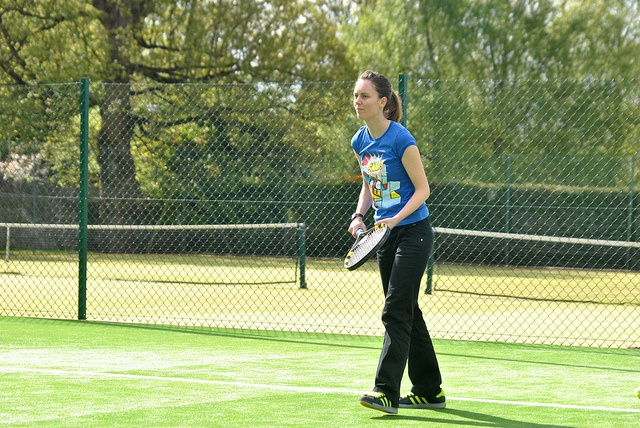Describe the objects in this image and their specific colors. I can see people in olive, black, tan, blue, and lightgray tones and tennis racket in olive, lightgray, black, darkgray, and gray tones in this image. 